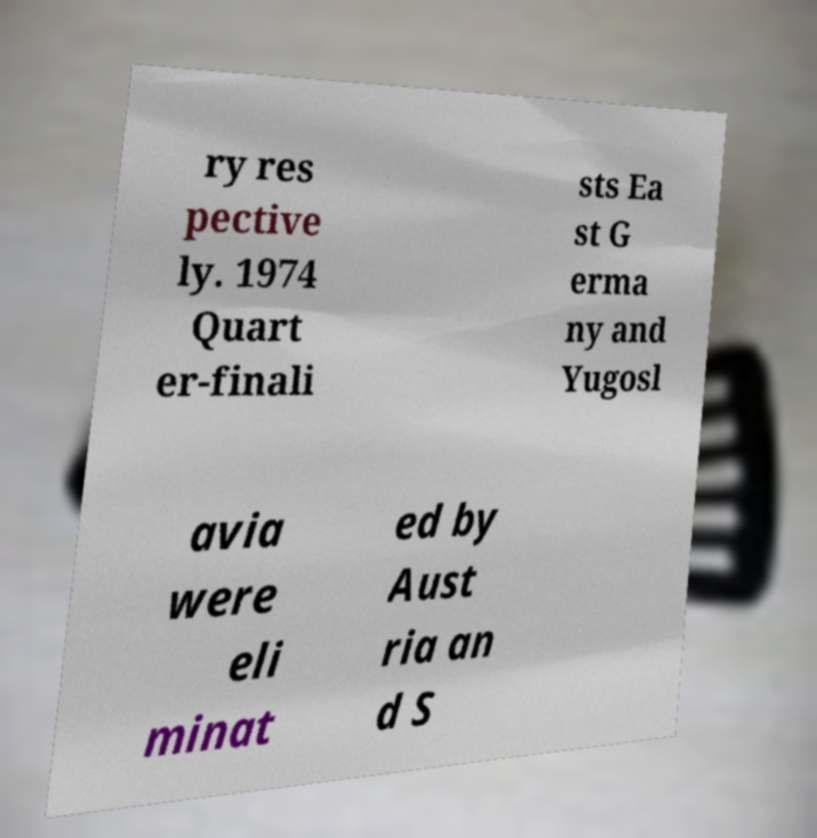Could you extract and type out the text from this image? ry res pective ly. 1974 Quart er-finali sts Ea st G erma ny and Yugosl avia were eli minat ed by Aust ria an d S 